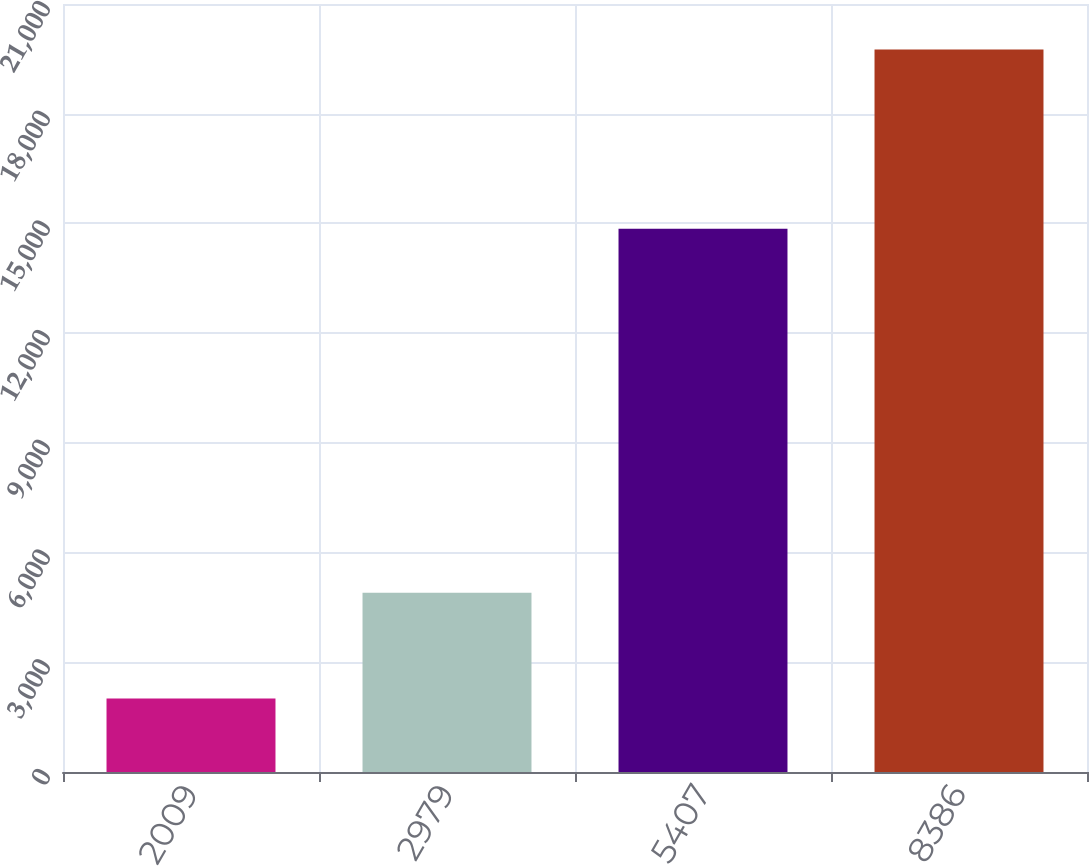<chart> <loc_0><loc_0><loc_500><loc_500><bar_chart><fcel>2009<fcel>2979<fcel>5407<fcel>8386<nl><fcel>2007<fcel>4900<fcel>14855<fcel>19755<nl></chart> 